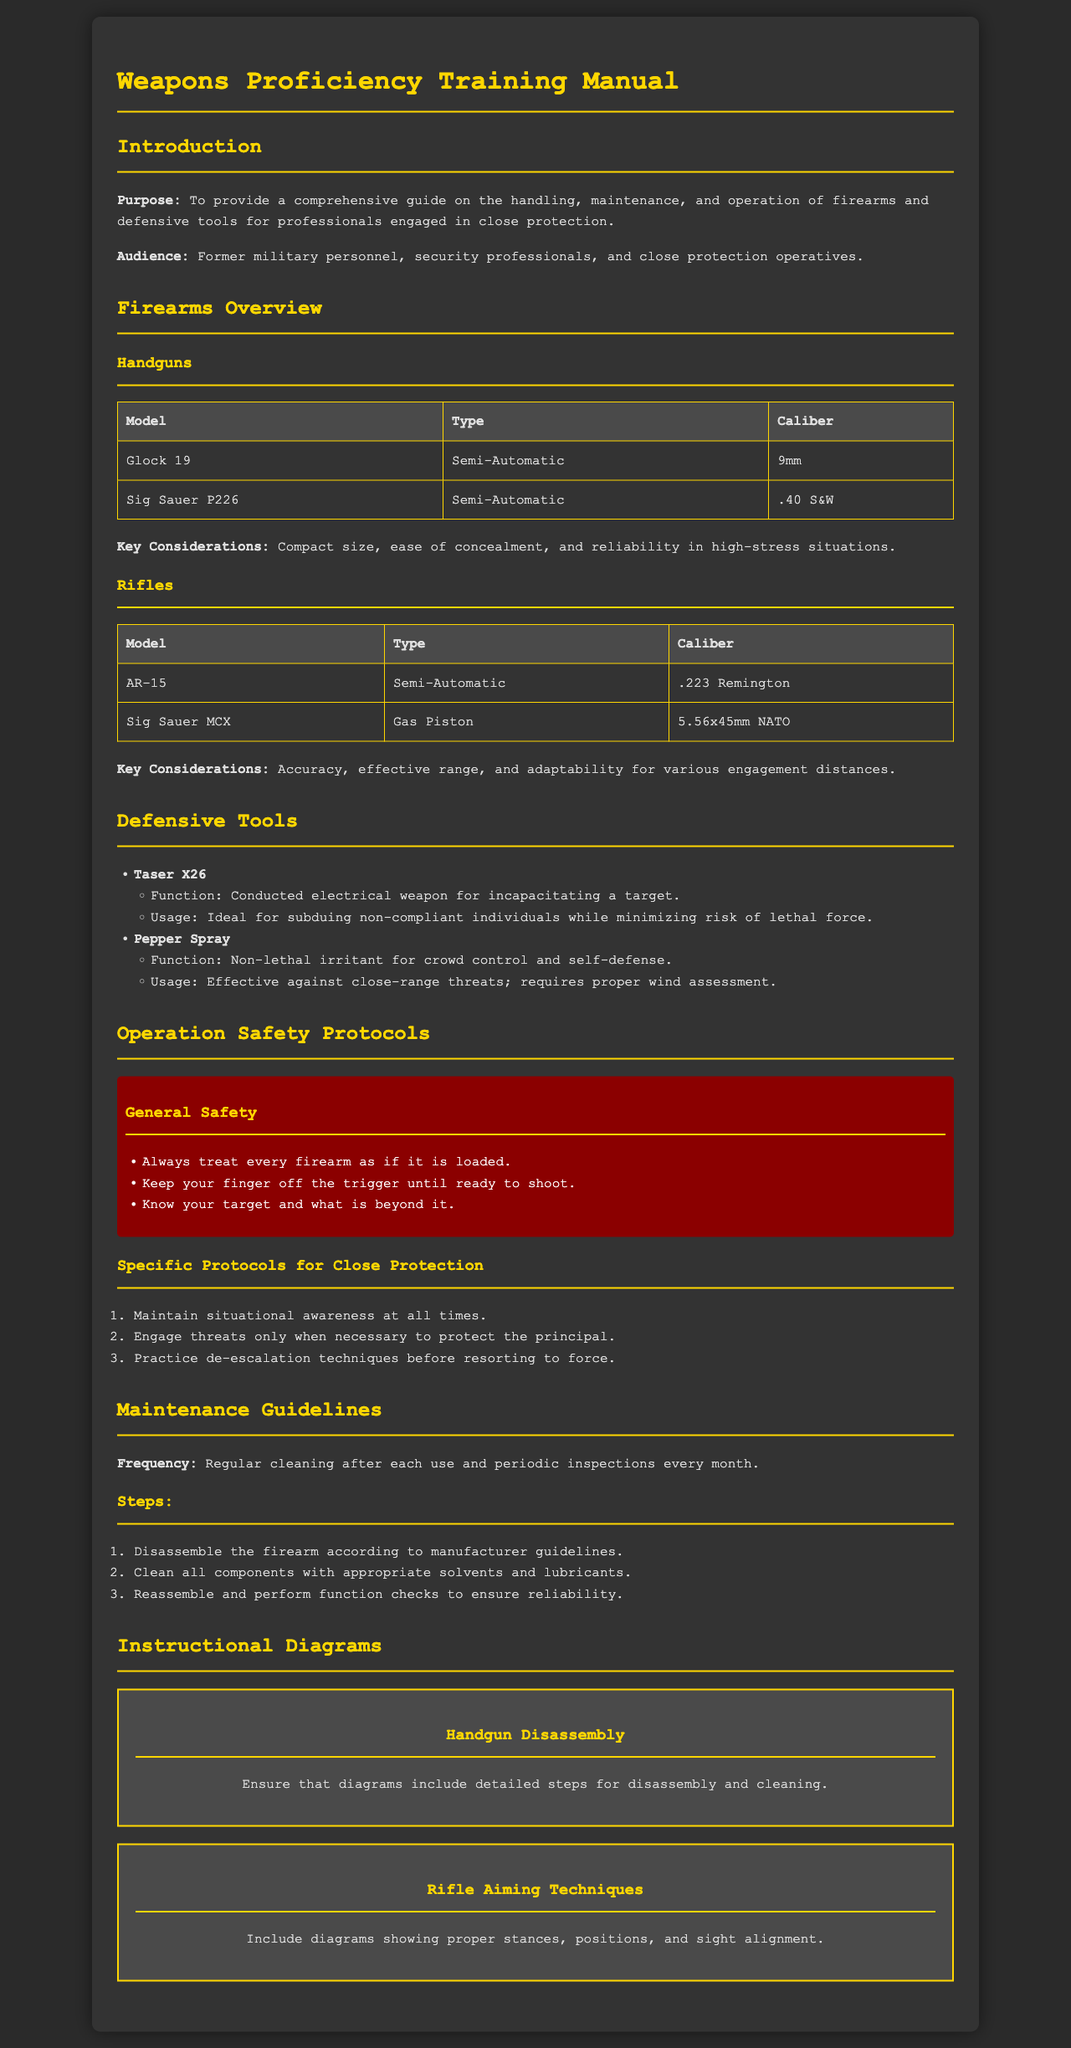What is the purpose of the manual? The purpose is to provide a comprehensive guide on the handling, maintenance, and operation of firearms and defensive tools for professionals engaged in close protection.
Answer: Comprehensive guide What types of firearms are covered in the manual? The manual covers handguns and rifles as two main categories of firearms for proficiency training.
Answer: Handguns and rifles What is the caliber of the Glock 19? The Glock 19 is specifically listed with its caliber in the firearms overview.
Answer: 9mm What is the function of the Taser X26? The function is provided under defensive tools, detailing its purpose in incapacitating a target.
Answer: Conducted electrical weapon How often should firearms be inspected? The manual specifies frequency guidelines for maintenance, including inspections.
Answer: Monthly What is the first step in the maintenance guidelines? The first step outlines what should be done immediately after disassembling the firearm.
Answer: Disassemble What document section addresses operation safety protocols? The section specifically dedicated to safety protocols is where general and specific safety measures are outlined.
Answer: Operation Safety Protocols What is emphasized for close protection operatives regarding engagement? The manual emphasizes engaging only when necessary to protect the principal directly within safety protocols.
Answer: Necessary How should pepper spray be used effectively? The usage guidelines for pepper spray include considerations such as wind assessment, detailed in the defensive tools section.
Answer: Proper wind assessment 